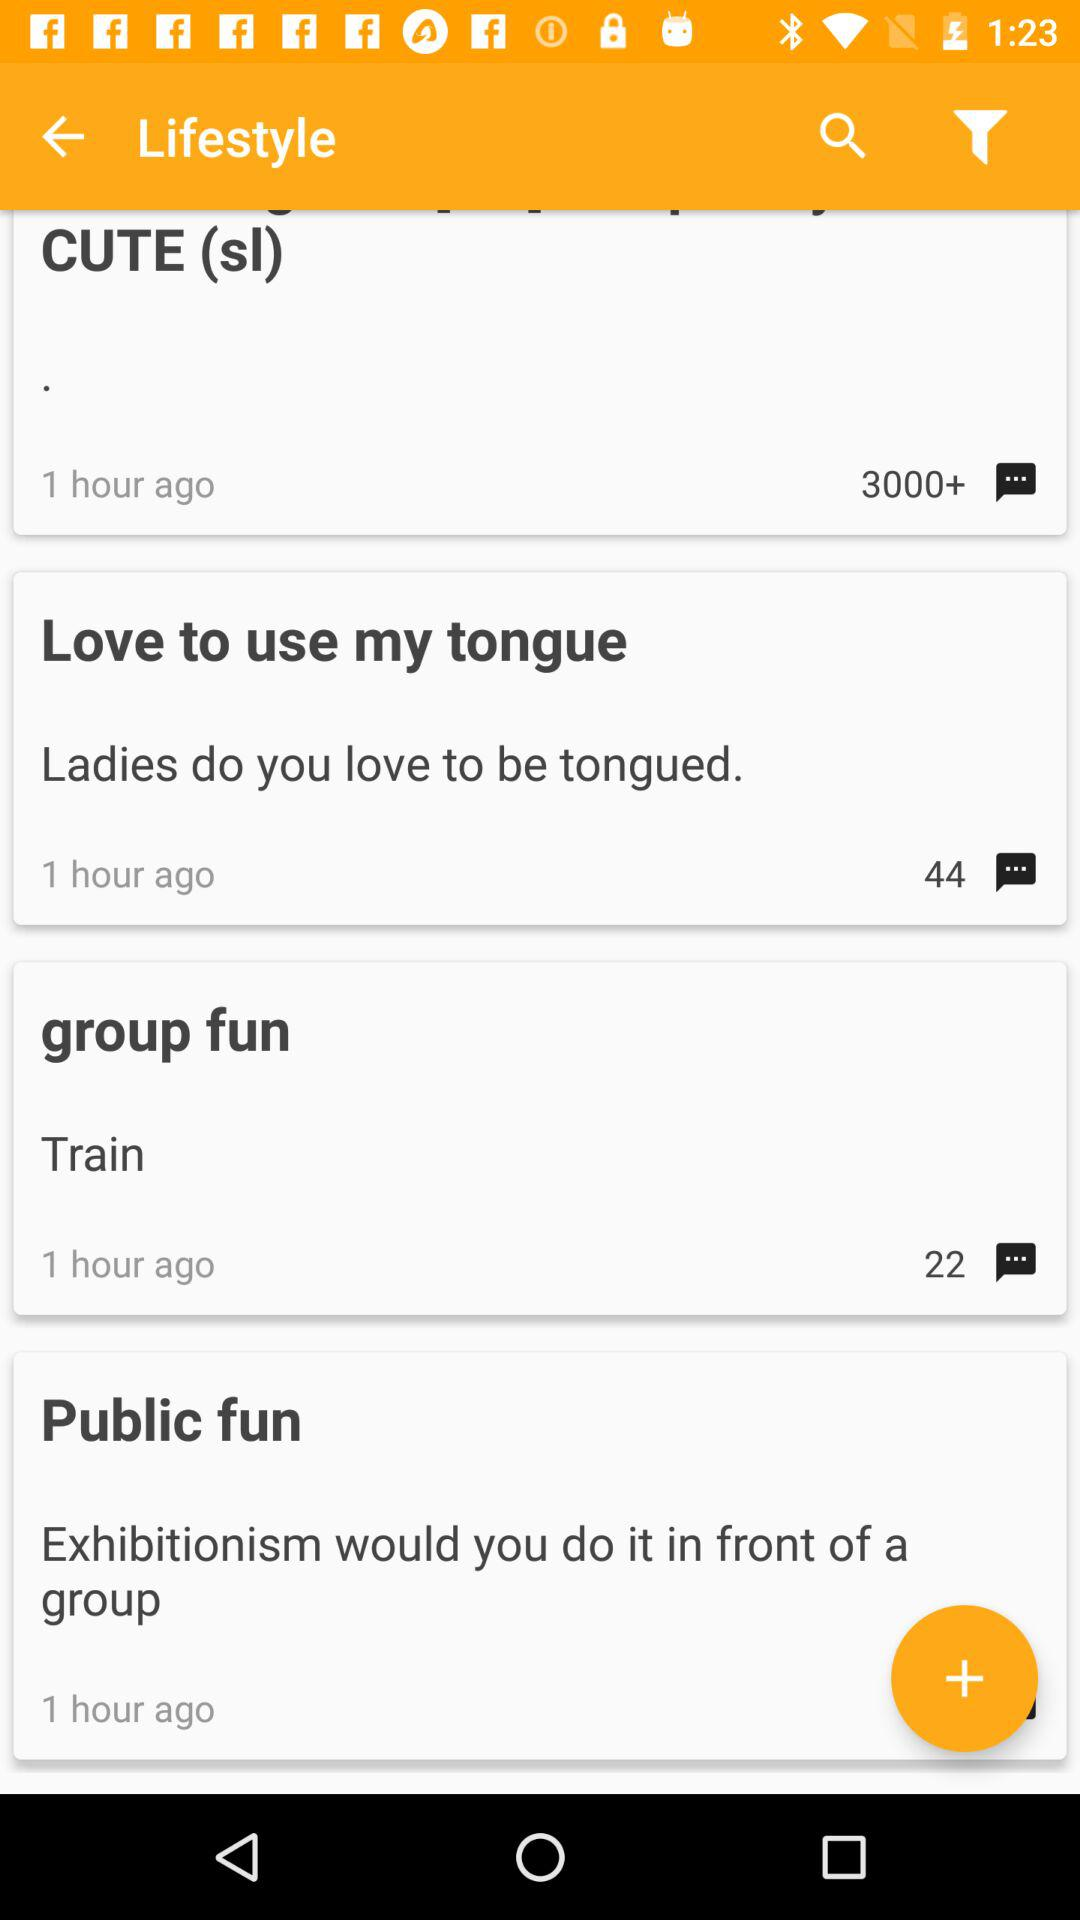When was the comment posted?
When the provided information is insufficient, respond with <no answer>. <no answer> 